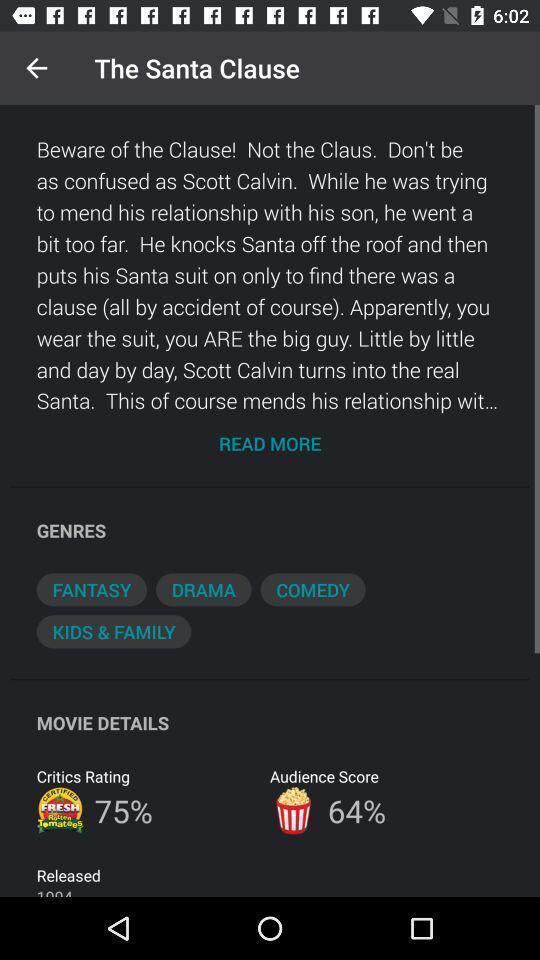Describe the content in this image. Page displaying detail description of a movie in streaming app. 